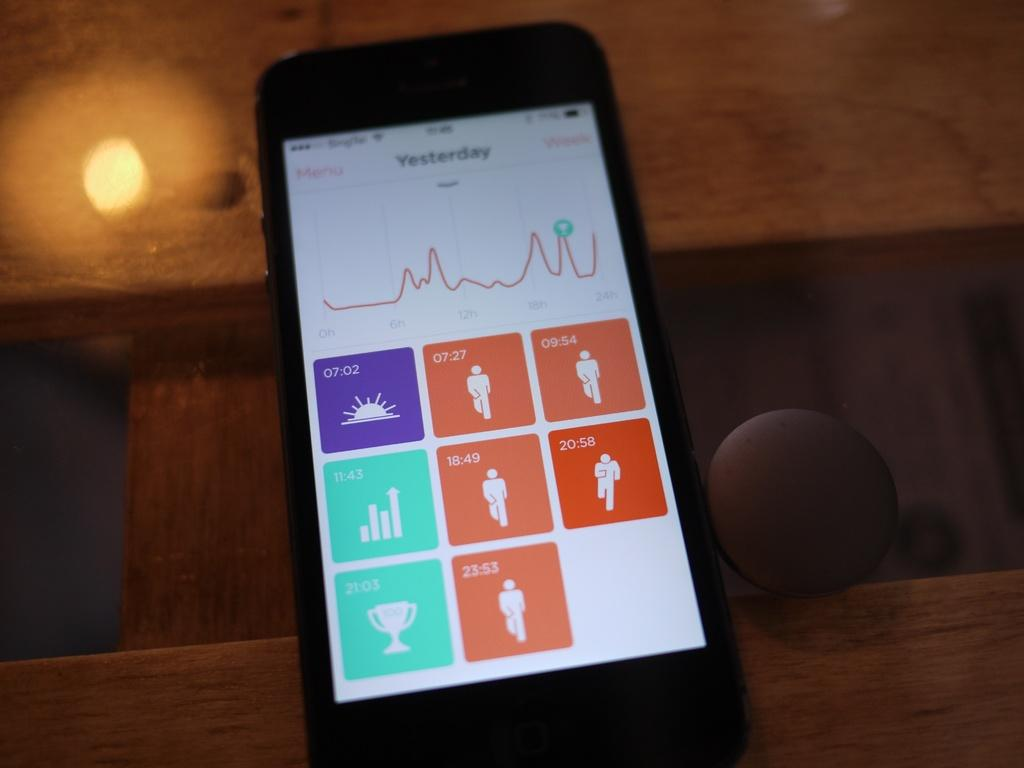<image>
Describe the image concisely. A cell phone with an app displayed showing timed activities from yesterday 